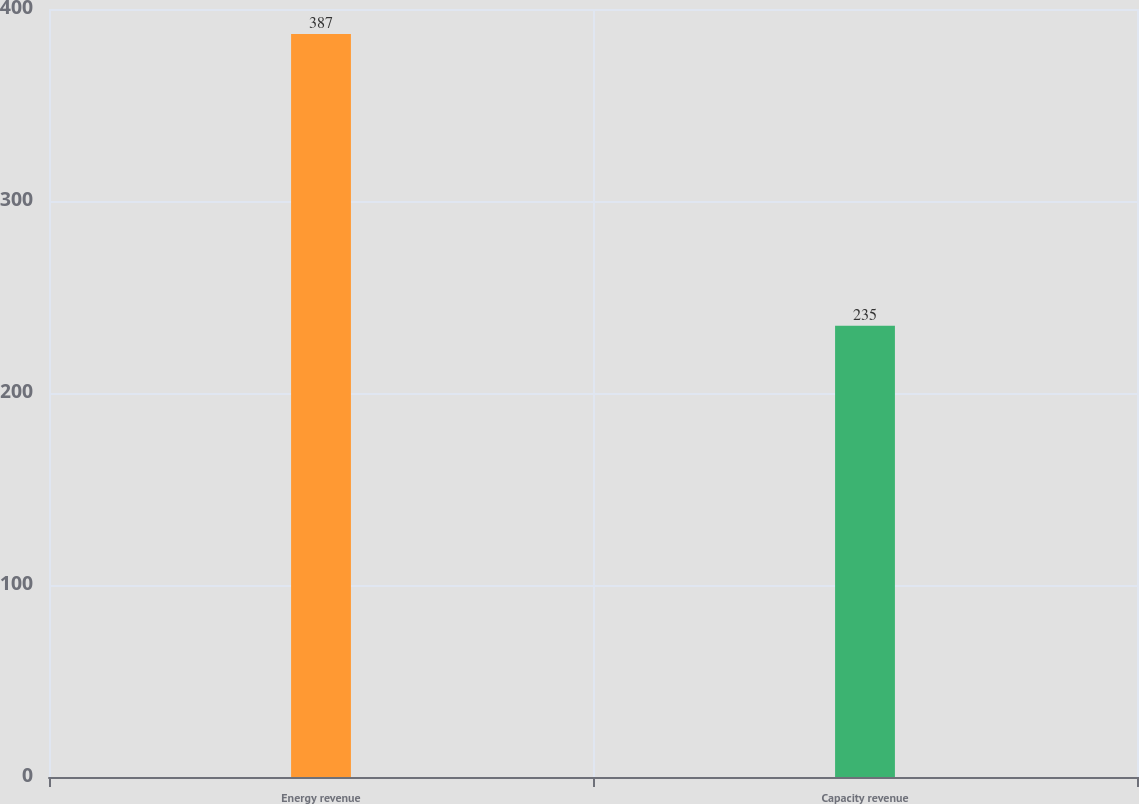<chart> <loc_0><loc_0><loc_500><loc_500><bar_chart><fcel>Energy revenue<fcel>Capacity revenue<nl><fcel>387<fcel>235<nl></chart> 